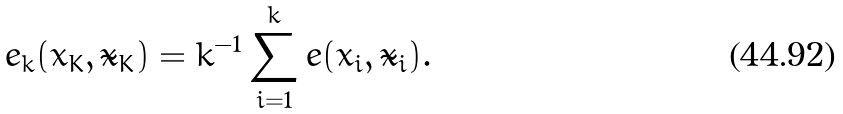<formula> <loc_0><loc_0><loc_500><loc_500>e _ { k } ( x _ { K } , \tilde { x } _ { K } ) = k ^ { - 1 } \sum _ { i = 1 } ^ { k } e ( x _ { i } , \tilde { x } _ { i } ) .</formula> 